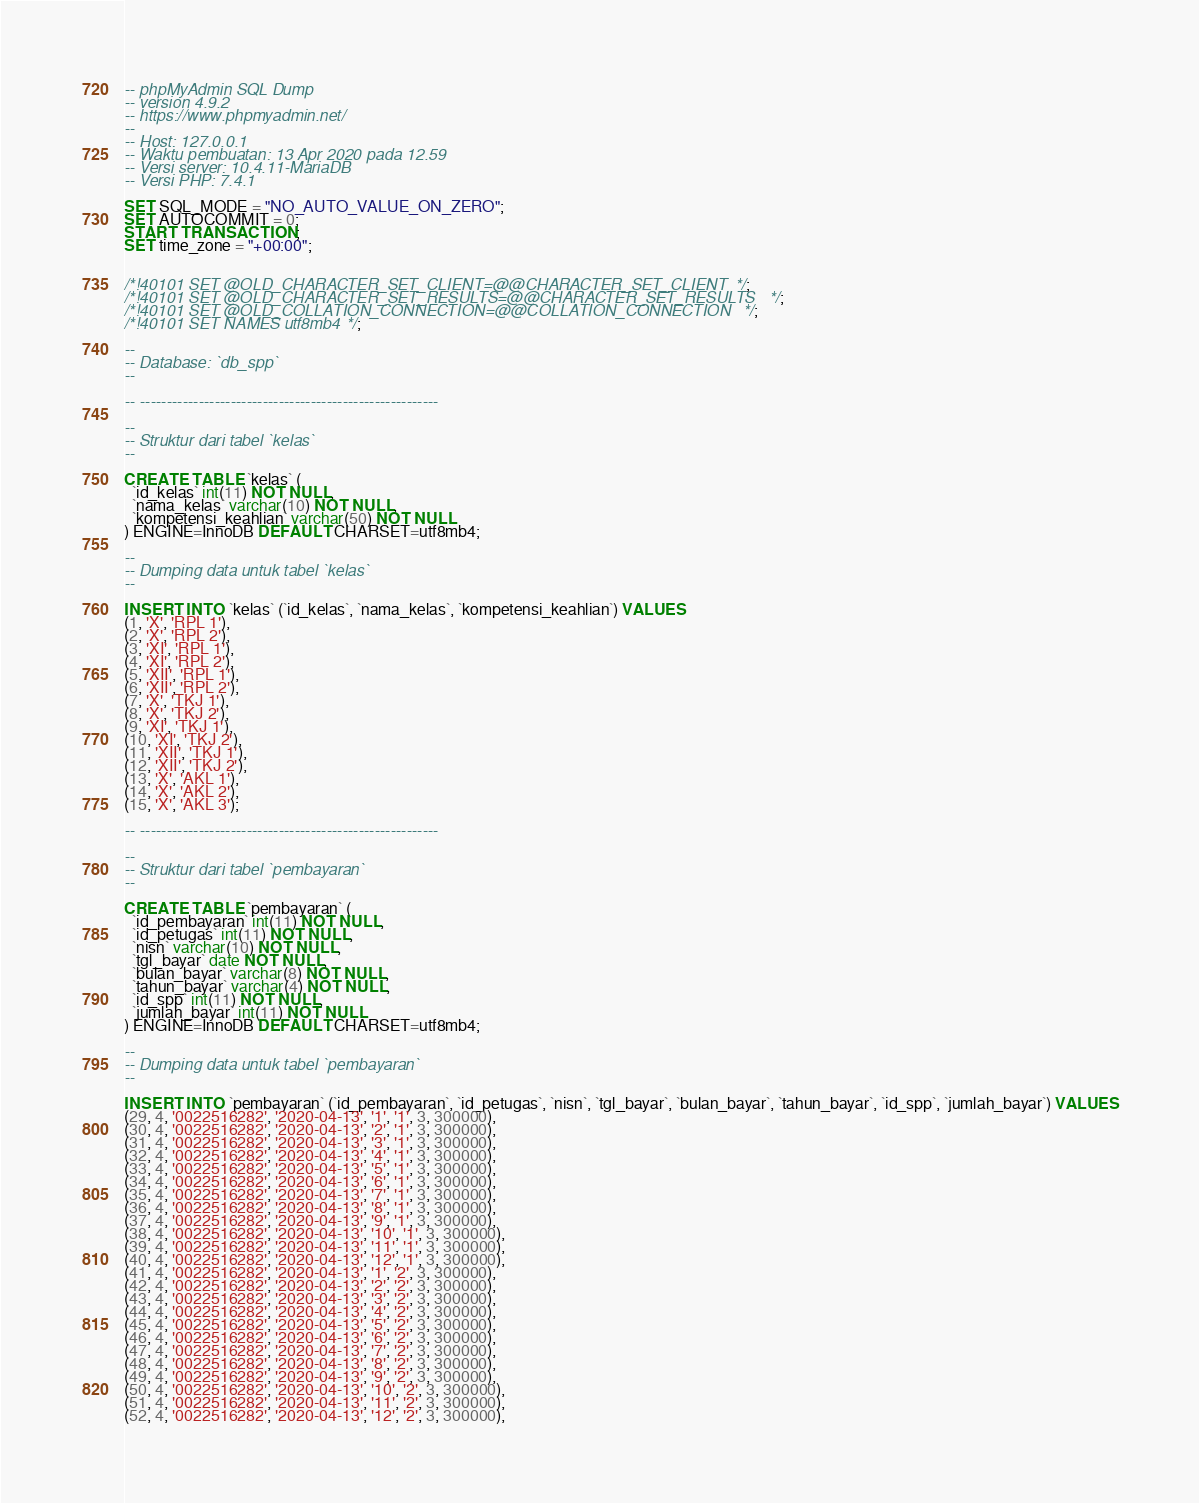<code> <loc_0><loc_0><loc_500><loc_500><_SQL_>-- phpMyAdmin SQL Dump
-- version 4.9.2
-- https://www.phpmyadmin.net/
--
-- Host: 127.0.0.1
-- Waktu pembuatan: 13 Apr 2020 pada 12.59
-- Versi server: 10.4.11-MariaDB
-- Versi PHP: 7.4.1

SET SQL_MODE = "NO_AUTO_VALUE_ON_ZERO";
SET AUTOCOMMIT = 0;
START TRANSACTION;
SET time_zone = "+00:00";


/*!40101 SET @OLD_CHARACTER_SET_CLIENT=@@CHARACTER_SET_CLIENT */;
/*!40101 SET @OLD_CHARACTER_SET_RESULTS=@@CHARACTER_SET_RESULTS */;
/*!40101 SET @OLD_COLLATION_CONNECTION=@@COLLATION_CONNECTION */;
/*!40101 SET NAMES utf8mb4 */;

--
-- Database: `db_spp`
--

-- --------------------------------------------------------

--
-- Struktur dari tabel `kelas`
--

CREATE TABLE `kelas` (
  `id_kelas` int(11) NOT NULL,
  `nama_kelas` varchar(10) NOT NULL,
  `kompetensi_keahlian` varchar(50) NOT NULL
) ENGINE=InnoDB DEFAULT CHARSET=utf8mb4;

--
-- Dumping data untuk tabel `kelas`
--

INSERT INTO `kelas` (`id_kelas`, `nama_kelas`, `kompetensi_keahlian`) VALUES
(1, 'X', 'RPL 1'),
(2, 'X', 'RPL 2'),
(3, 'XI', 'RPL 1'),
(4, 'XI', 'RPL 2'),
(5, 'XII', 'RPL 1'),
(6, 'XII', 'RPL 2'),
(7, 'X', 'TKJ 1'),
(8, 'X', 'TKJ 2'),
(9, 'XI', 'TKJ 1'),
(10, 'XI', 'TKJ 2'),
(11, 'XII', 'TKJ 1'),
(12, 'XII', 'TKJ 2'),
(13, 'X', 'AKL 1'),
(14, 'X', 'AKL 2'),
(15, 'X', 'AKL 3');

-- --------------------------------------------------------

--
-- Struktur dari tabel `pembayaran`
--

CREATE TABLE `pembayaran` (
  `id_pembayaran` int(11) NOT NULL,
  `id_petugas` int(11) NOT NULL,
  `nisn` varchar(10) NOT NULL,
  `tgl_bayar` date NOT NULL,
  `bulan_bayar` varchar(8) NOT NULL,
  `tahun_bayar` varchar(4) NOT NULL,
  `id_spp` int(11) NOT NULL,
  `jumlah_bayar` int(11) NOT NULL
) ENGINE=InnoDB DEFAULT CHARSET=utf8mb4;

--
-- Dumping data untuk tabel `pembayaran`
--

INSERT INTO `pembayaran` (`id_pembayaran`, `id_petugas`, `nisn`, `tgl_bayar`, `bulan_bayar`, `tahun_bayar`, `id_spp`, `jumlah_bayar`) VALUES
(29, 4, '0022516282', '2020-04-13', '1', '1', 3, 300000),
(30, 4, '0022516282', '2020-04-13', '2', '1', 3, 300000),
(31, 4, '0022516282', '2020-04-13', '3', '1', 3, 300000),
(32, 4, '0022516282', '2020-04-13', '4', '1', 3, 300000),
(33, 4, '0022516282', '2020-04-13', '5', '1', 3, 300000),
(34, 4, '0022516282', '2020-04-13', '6', '1', 3, 300000),
(35, 4, '0022516282', '2020-04-13', '7', '1', 3, 300000),
(36, 4, '0022516282', '2020-04-13', '8', '1', 3, 300000),
(37, 4, '0022516282', '2020-04-13', '9', '1', 3, 300000),
(38, 4, '0022516282', '2020-04-13', '10', '1', 3, 300000),
(39, 4, '0022516282', '2020-04-13', '11', '1', 3, 300000),
(40, 4, '0022516282', '2020-04-13', '12', '1', 3, 300000),
(41, 4, '0022516282', '2020-04-13', '1', '2', 3, 300000),
(42, 4, '0022516282', '2020-04-13', '2', '2', 3, 300000),
(43, 4, '0022516282', '2020-04-13', '3', '2', 3, 300000),
(44, 4, '0022516282', '2020-04-13', '4', '2', 3, 300000),
(45, 4, '0022516282', '2020-04-13', '5', '2', 3, 300000),
(46, 4, '0022516282', '2020-04-13', '6', '2', 3, 300000),
(47, 4, '0022516282', '2020-04-13', '7', '2', 3, 300000),
(48, 4, '0022516282', '2020-04-13', '8', '2', 3, 300000),
(49, 4, '0022516282', '2020-04-13', '9', '2', 3, 300000),
(50, 4, '0022516282', '2020-04-13', '10', '2', 3, 300000),
(51, 4, '0022516282', '2020-04-13', '11', '2', 3, 300000),
(52, 4, '0022516282', '2020-04-13', '12', '2', 3, 300000),</code> 